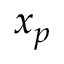<formula> <loc_0><loc_0><loc_500><loc_500>x _ { p }</formula> 